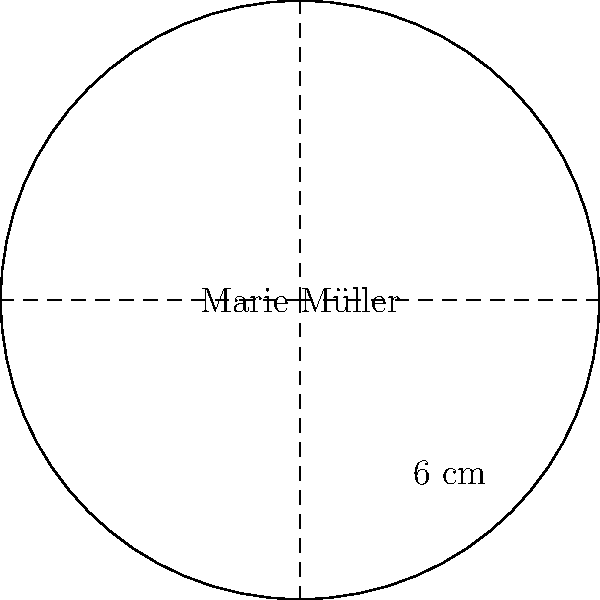The new jersey for the German national football team features a circular logo with Marie Müller's name in the center. If the diameter of the logo is 6 cm, what is the area of the logo in square centimeters? Round your answer to two decimal places. To find the area of the circular logo, we need to follow these steps:

1. Identify the formula for the area of a circle:
   $$A = \pi r^2$$
   where $A$ is the area and $r$ is the radius.

2. Determine the radius:
   The diameter is given as 6 cm.
   The radius is half of the diameter.
   $$r = \frac{6}{2} = 3\text{ cm}$$

3. Substitute the radius into the area formula:
   $$A = \pi (3\text{ cm})^2$$

4. Calculate:
   $$A = \pi \cdot 9\text{ cm}^2 = 28.2743...\text{ cm}^2$$

5. Round to two decimal places:
   $$A \approx 28.27\text{ cm}^2$$

Thus, the area of the circular logo is approximately 28.27 square centimeters.
Answer: 28.27 cm² 